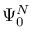Convert formula to latex. <formula><loc_0><loc_0><loc_500><loc_500>\Psi _ { 0 } ^ { N }</formula> 